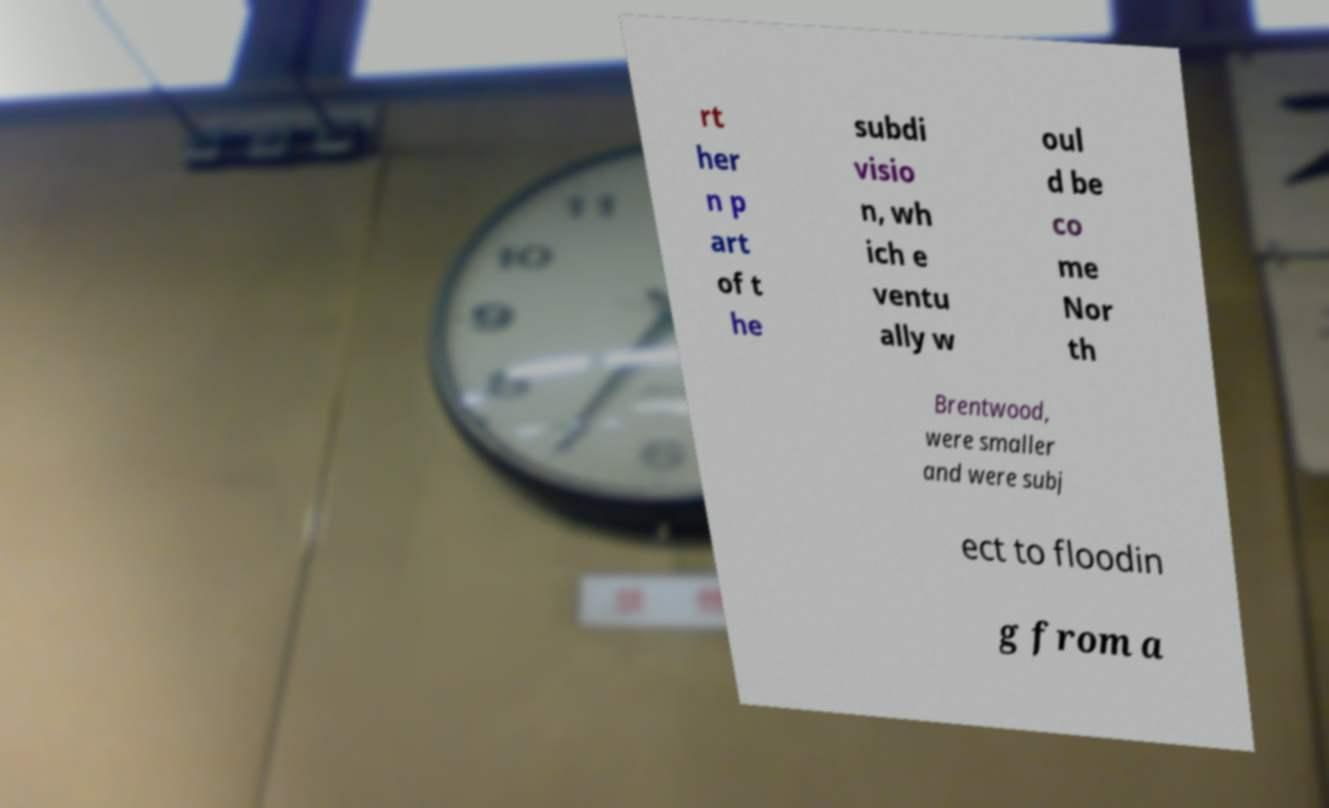Can you read and provide the text displayed in the image?This photo seems to have some interesting text. Can you extract and type it out for me? rt her n p art of t he subdi visio n, wh ich e ventu ally w oul d be co me Nor th Brentwood, were smaller and were subj ect to floodin g from a 